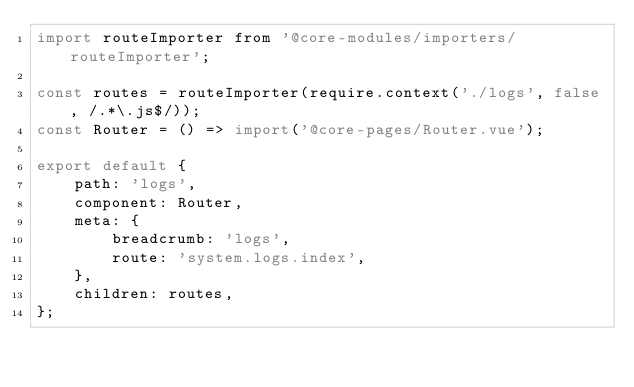<code> <loc_0><loc_0><loc_500><loc_500><_JavaScript_>import routeImporter from '@core-modules/importers/routeImporter';

const routes = routeImporter(require.context('./logs', false, /.*\.js$/));
const Router = () => import('@core-pages/Router.vue');

export default {
    path: 'logs',
    component: Router,
    meta: {
        breadcrumb: 'logs',
        route: 'system.logs.index',
    },
    children: routes,
};
</code> 